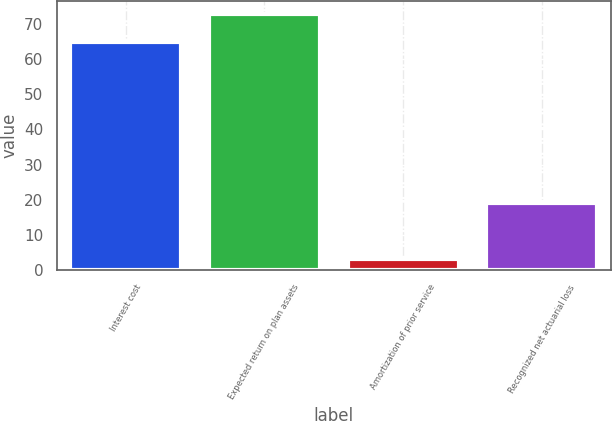Convert chart to OTSL. <chart><loc_0><loc_0><loc_500><loc_500><bar_chart><fcel>Interest cost<fcel>Expected return on plan assets<fcel>Amortization of prior service<fcel>Recognized net actuarial loss<nl><fcel>65<fcel>73<fcel>3<fcel>19<nl></chart> 